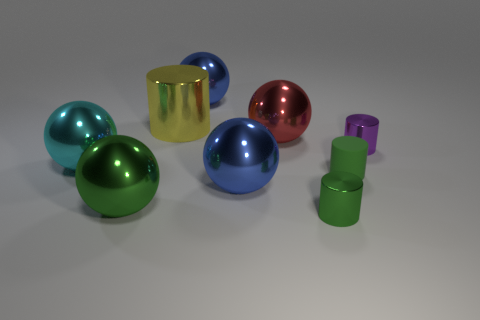Are there any tiny green metal objects left of the large cyan thing?
Provide a short and direct response. No. The cylinder that is to the left of the blue ball in front of the sphere behind the large yellow metallic thing is what color?
Your response must be concise. Yellow. Do the purple metal thing and the small green matte thing have the same shape?
Keep it short and to the point. Yes. What color is the large cylinder that is the same material as the big green sphere?
Your answer should be compact. Yellow. What number of objects are big blue shiny things behind the yellow metallic cylinder or small things?
Your answer should be compact. 4. What is the size of the shiny thing that is on the right side of the matte object?
Offer a terse response. Small. There is a purple cylinder; is it the same size as the green shiny thing on the right side of the green metal ball?
Make the answer very short. Yes. What is the color of the big ball on the right side of the blue sphere that is in front of the cyan metallic ball?
Make the answer very short. Red. How many other objects are there of the same color as the rubber cylinder?
Provide a short and direct response. 2. What size is the purple cylinder?
Your answer should be compact. Small. 